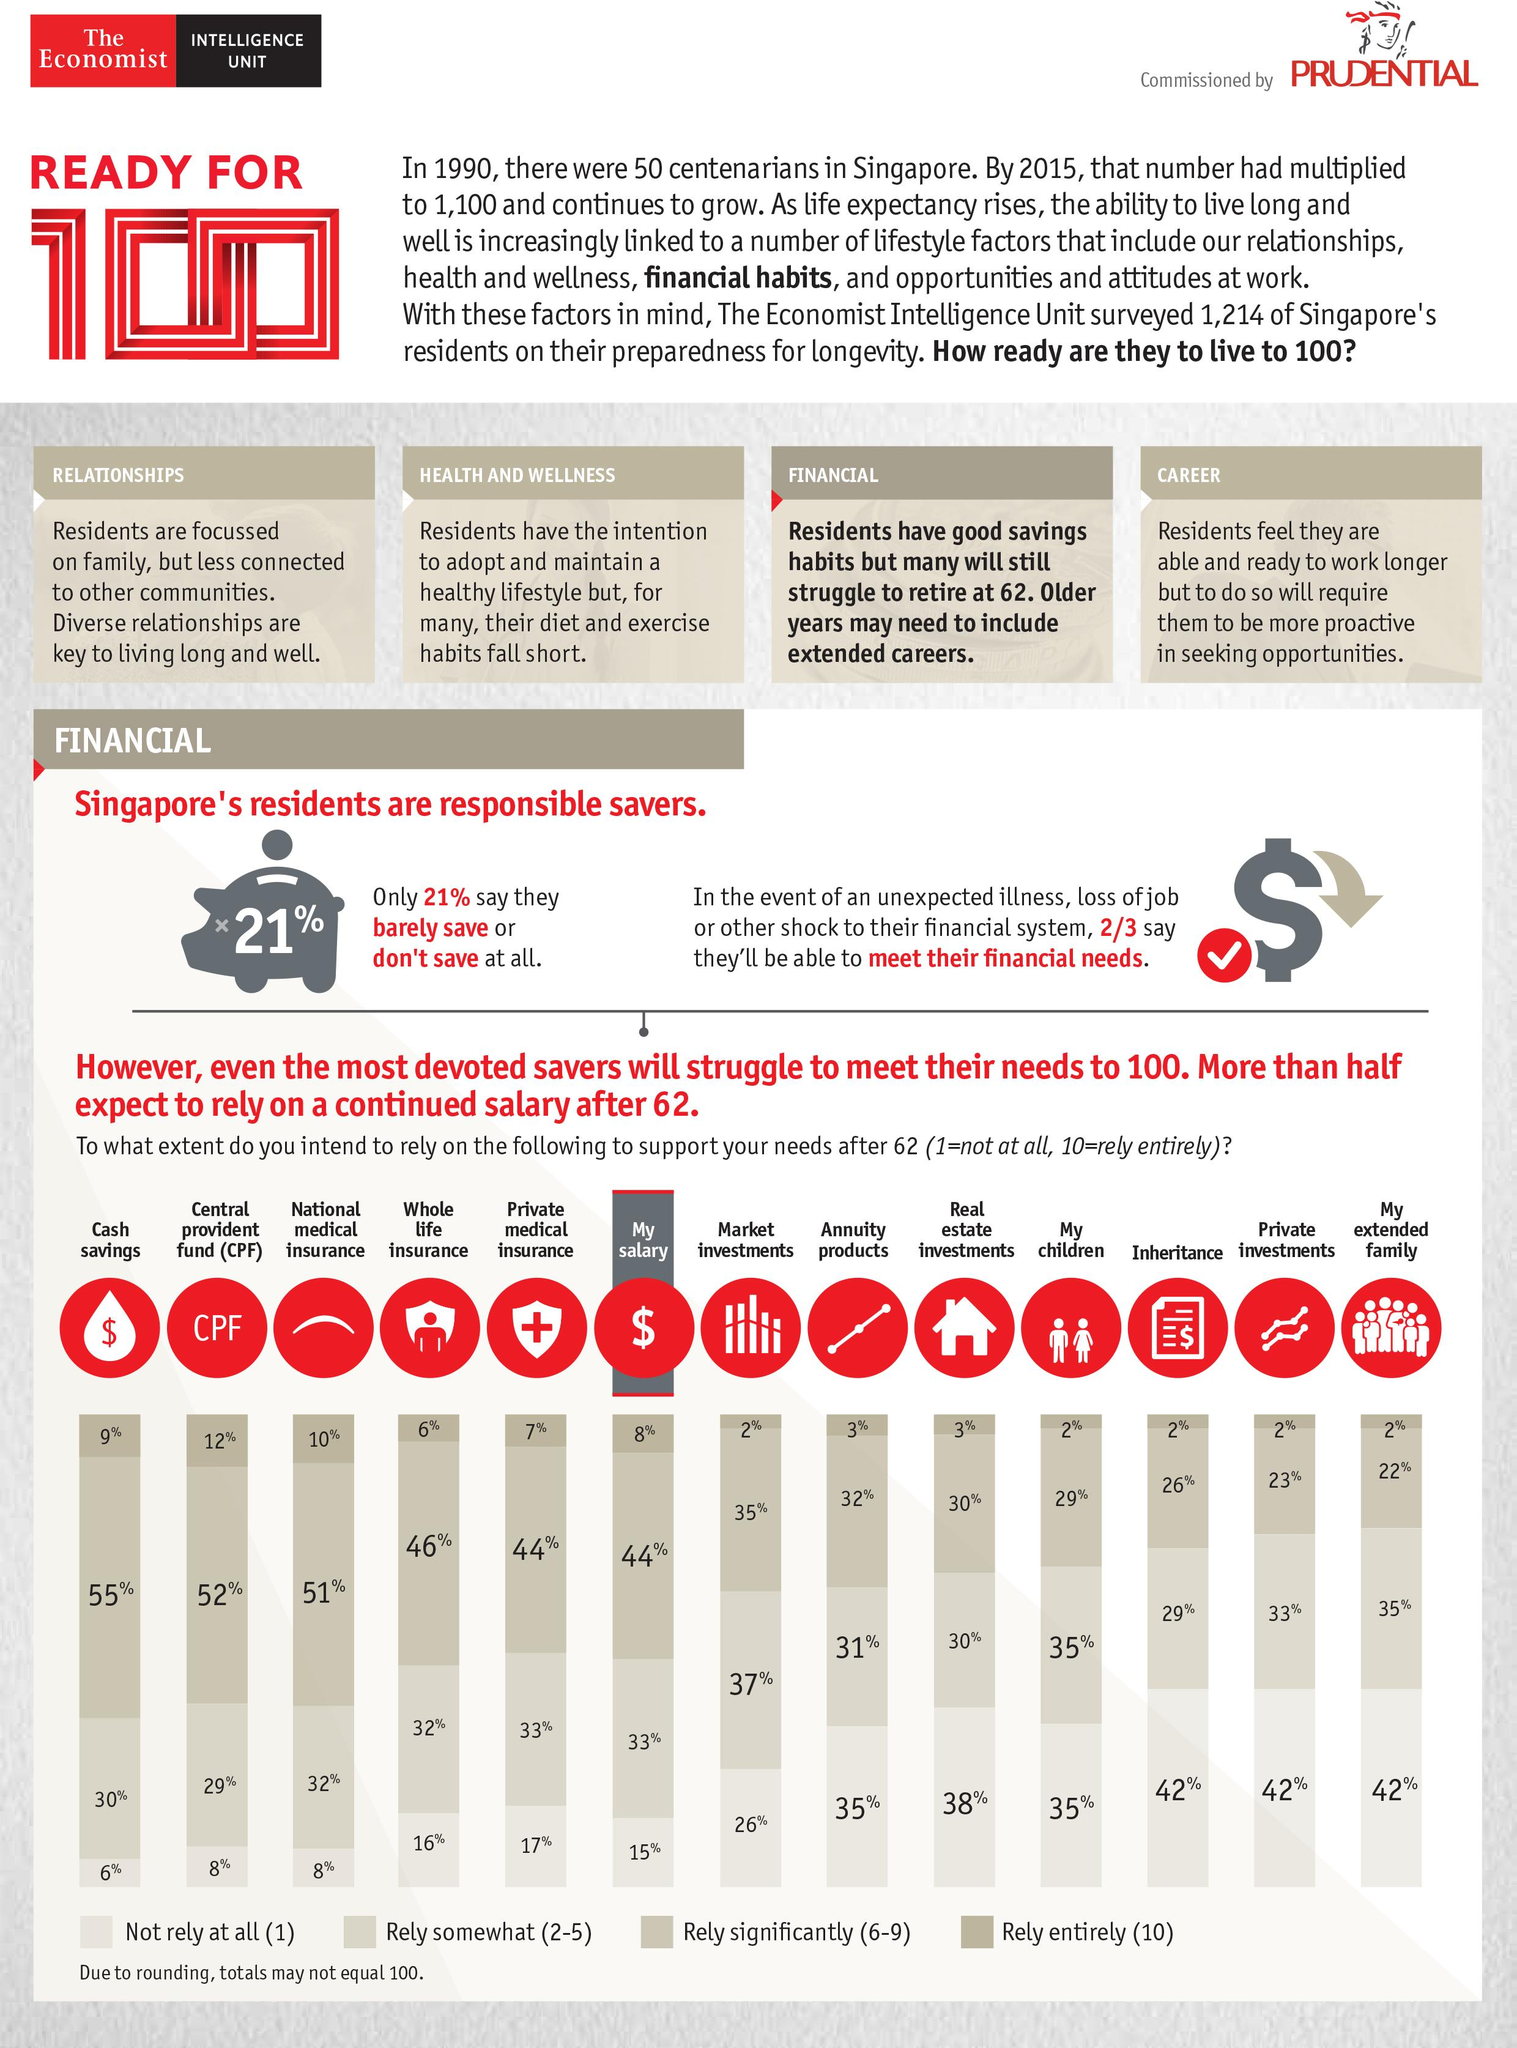Mention a couple of crucial points in this snapshot. According to the data, a significant proportion of residents, approximately one-third, are unable to meet their financial needs in case of an emergency. Approximately 35% of people will not rely on their children for any financial support whatsoever. According to a survey, 33% of people plan to rely somewhat on their salary for financial support. According to a recent survey, 51% of people indicated that they would rely heavily on national medical insurance for their healthcare needs. According to the data, only 9% of people will rely entirely on cash savings. 